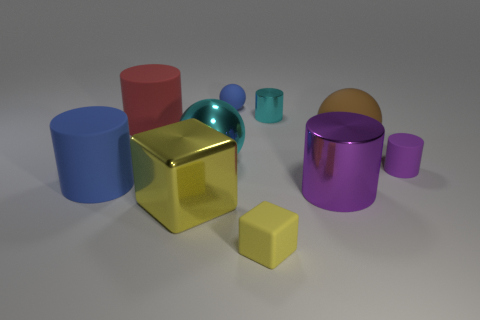The cyan object in front of the big rubber object right of the tiny yellow rubber object is what shape?
Offer a terse response. Sphere. Are there any other things of the same color as the metal sphere?
Provide a short and direct response. Yes. What shape is the tiny thing left of the tiny matte cube?
Offer a very short reply. Sphere. What shape is the small thing that is in front of the red matte cylinder and behind the small yellow matte thing?
Provide a short and direct response. Cylinder. How many green things are rubber blocks or big matte objects?
Offer a very short reply. 0. Do the tiny cylinder behind the red rubber object and the large metallic cylinder have the same color?
Your answer should be compact. No. There is a blue object in front of the metal thing behind the brown rubber thing; what size is it?
Give a very brief answer. Large. There is a cube that is the same size as the purple matte thing; what is it made of?
Provide a succinct answer. Rubber. How many other objects are there of the same size as the red cylinder?
Provide a short and direct response. 5. What number of spheres are large purple things or tiny blue things?
Provide a short and direct response. 1. 